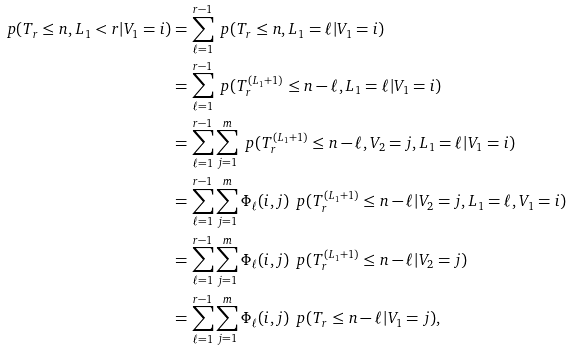Convert formula to latex. <formula><loc_0><loc_0><loc_500><loc_500>\ p ( T _ { r } \leq n , L _ { 1 } < r | V _ { 1 } = i ) & = \sum _ { \ell = 1 } ^ { r - 1 } \ p ( T _ { r } \leq n , L _ { 1 } = \ell | V _ { 1 } = i ) \\ & = \sum _ { \ell = 1 } ^ { r - 1 } \ p ( T ^ { ( L _ { 1 } + 1 ) } _ { r } \leq n - \ell , L _ { 1 } = \ell | V _ { 1 } = i ) \\ & = \sum _ { \ell = 1 } ^ { r - 1 } \sum _ { j = 1 } ^ { m } \ p ( T ^ { ( L _ { 1 } + 1 ) } _ { r } \leq n - \ell , V _ { 2 } = j , L _ { 1 } = \ell | V _ { 1 } = i ) \\ & = \sum _ { \ell = 1 } ^ { r - 1 } \sum _ { j = 1 } ^ { m } \Phi _ { \ell } ( i , j ) \, \ p ( T ^ { ( L _ { 1 } + 1 ) } _ { r } \leq n - \ell | V _ { 2 } = j , L _ { 1 } = \ell , V _ { 1 } = i ) \\ & = \sum _ { \ell = 1 } ^ { r - 1 } \sum _ { j = 1 } ^ { m } \Phi _ { \ell } ( i , j ) \, \ p ( T ^ { ( L _ { 1 } + 1 ) } _ { r } \leq n - \ell | V _ { 2 } = j ) \\ & = \sum _ { \ell = 1 } ^ { r - 1 } \sum _ { j = 1 } ^ { m } \Phi _ { \ell } ( i , j ) \, \ p ( T _ { r } \leq n - \ell | V _ { 1 } = j ) ,</formula> 